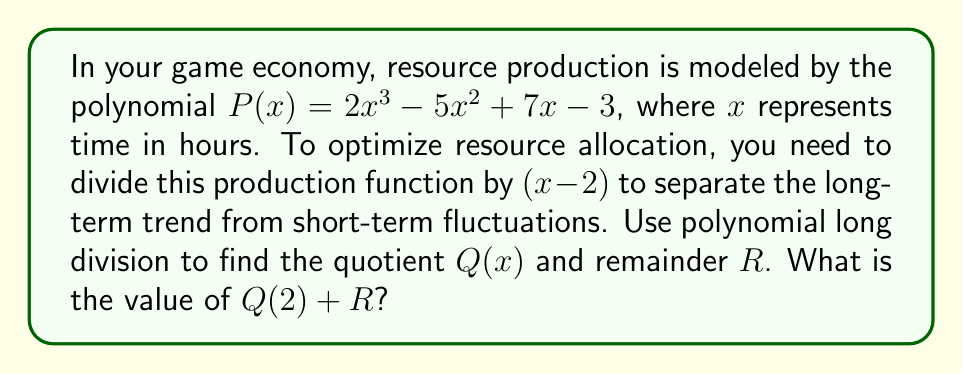Show me your answer to this math problem. Let's perform polynomial long division of $P(x)$ by $(x - 2)$:

$$\begin{array}{r}
2x^2 + 4x + 15 \\
x - 2 \enclose{longdiv}{2x^3 - 5x^2 + 7x - 3} \\
\underline{2x^3 - 4x^2} \\
-x^2 + 7x \\
\underline{-x^2 + 2x} \\
5x - 3 \\
\underline{5x - 10} \\
7
\end{array}$$

1) First, divide $2x^3$ by $x$, getting $2x^2$.
2) Multiply $(x - 2)$ by $2x^2$ and subtract from $2x^3 - 5x^2$.
3) Bring down $7x$.
4) Divide $-x^2$ by $x$, getting $-x$.
5) Multiply $(x - 2)$ by $-x$ and subtract from $-x^2 + 7x$.
6) Bring down $-3$.
7) Divide $5x$ by $x$, getting $5$.
8) Multiply $(x - 2)$ by $5$ and subtract from $5x - 3$.

Therefore, $Q(x) = 2x^2 + 4x + 15$ and $R = 7$.

To find $Q(2) + R$:
$Q(2) = 2(2)^2 + 4(2) + 15 = 2(4) + 8 + 15 = 8 + 8 + 15 = 31$

$Q(2) + R = 31 + 7 = 38$
Answer: 38 